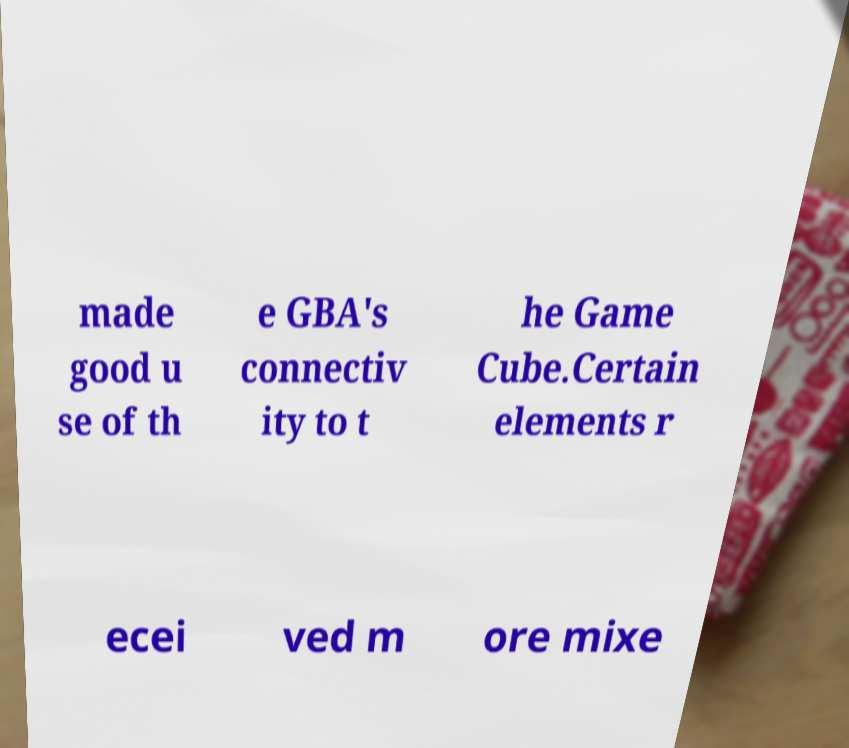Can you read and provide the text displayed in the image?This photo seems to have some interesting text. Can you extract and type it out for me? made good u se of th e GBA's connectiv ity to t he Game Cube.Certain elements r ecei ved m ore mixe 